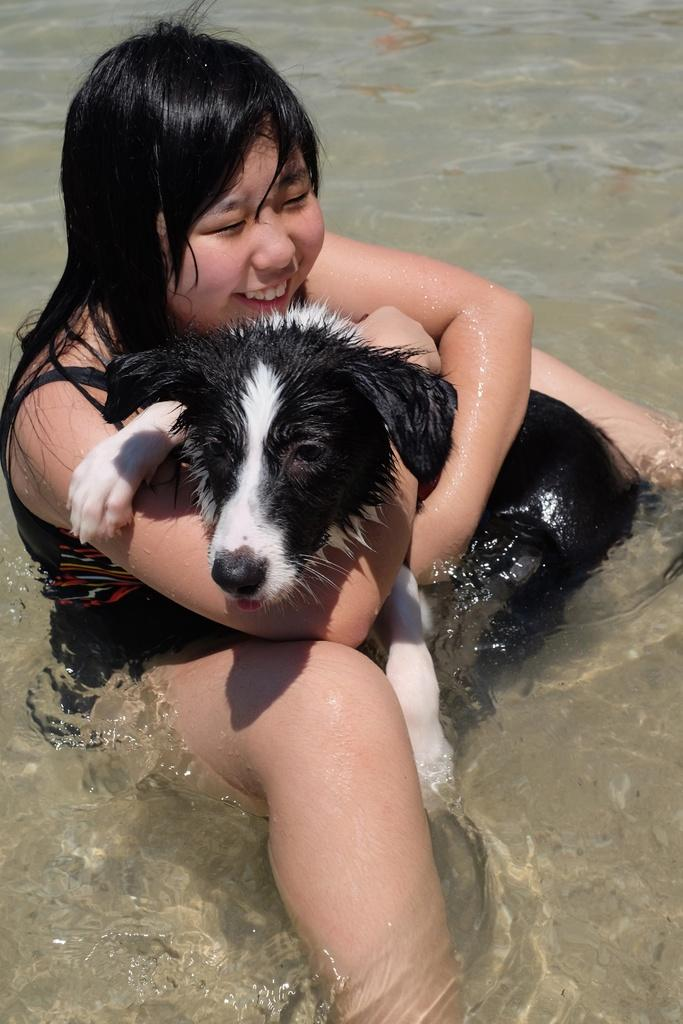Who is present in the image? There is a girl in the image. What is the girl holding? The girl is holding a dog. Where are the girl and the dog located? The girl and the dog are in the water. What type of knife is the girl using to cut the fan in the image? There is no knife, fan, or cutting activity present in the image. 